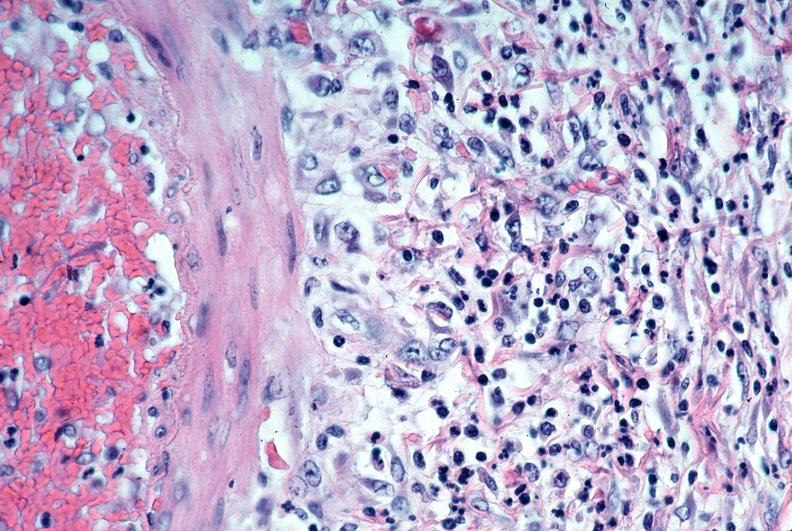where is this from?
Answer the question using a single word or phrase. Vasculature 